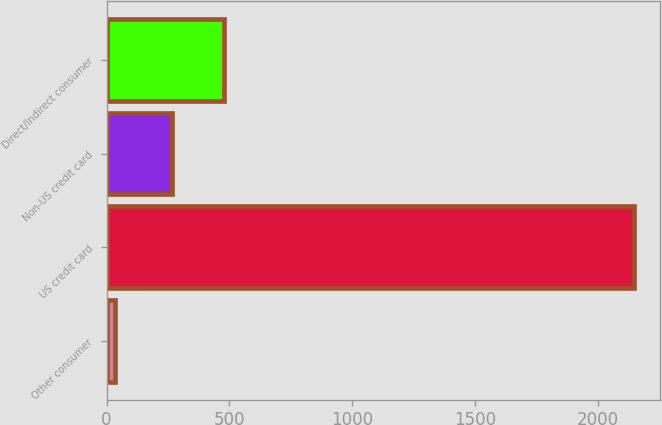<chart> <loc_0><loc_0><loc_500><loc_500><bar_chart><fcel>Other consumer<fcel>US credit card<fcel>Non-US credit card<fcel>Direct/Indirect consumer<nl><fcel>34<fcel>2144<fcel>266<fcel>477<nl></chart> 